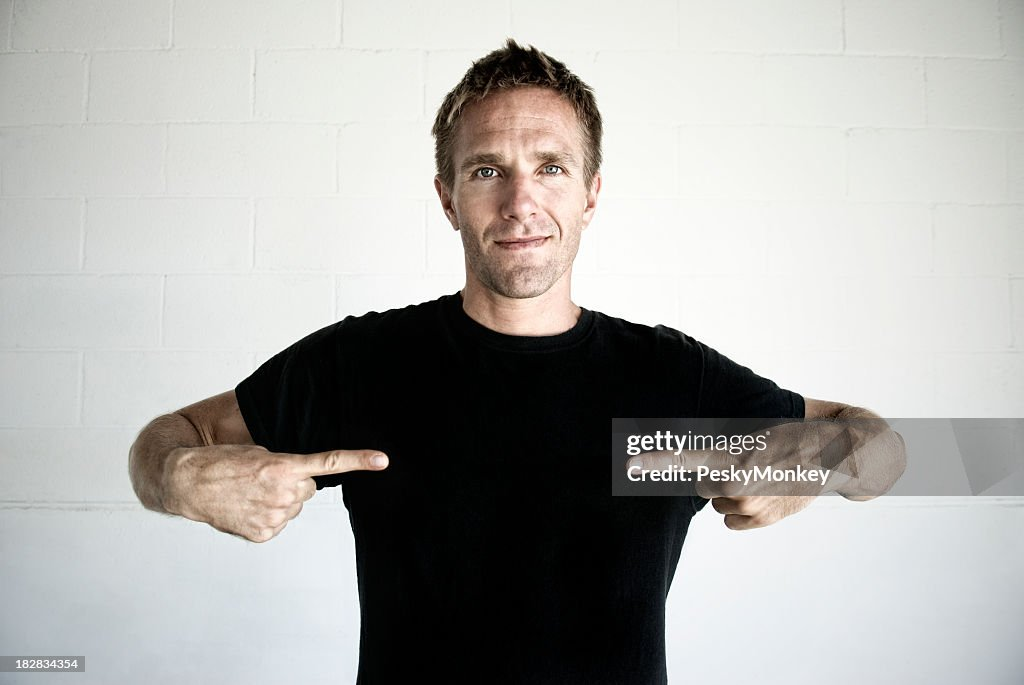Could the man be a part of a larger event or activity? It's plausible. His attire and demeanor appear casual and engaging, which could align with events like a community workshop, a team-building exercise, or even a casual TED-style talk. The emphasis seems to be on him sharing something of a personal or anecdotal nature, potentially as part of a storytelling session or a personal branding exercise. Might there be any particular reason he's wearing a plain black T-shirt? The plain black T-shirt acts as a neutral canvas and suggests that whatever he is promoting or discussing is tied more to him as a person rather than a branded product or service. This attire choice can be strategic to keep the audience's attention on the speaker's message rather than being distracted by logos or designs. It could also be a way to portray simplicity and authenticity, essential elements in personal storytelling or brand representation. 